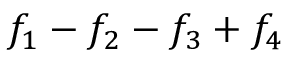Convert formula to latex. <formula><loc_0><loc_0><loc_500><loc_500>f _ { 1 } - f _ { 2 } - f _ { 3 } + f _ { 4 }</formula> 